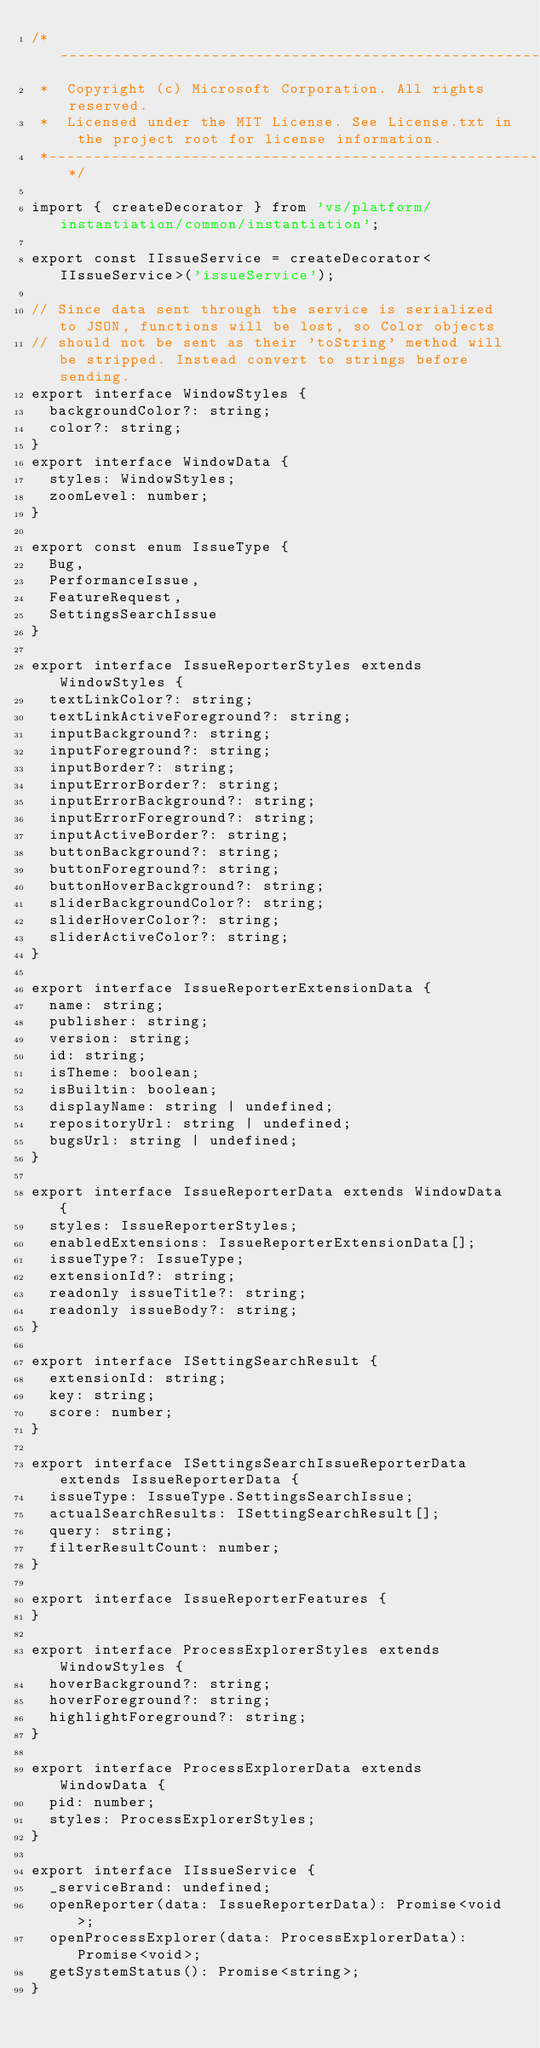<code> <loc_0><loc_0><loc_500><loc_500><_TypeScript_>/*---------------------------------------------------------------------------------------------
 *  Copyright (c) Microsoft Corporation. All rights reserved.
 *  Licensed under the MIT License. See License.txt in the project root for license information.
 *--------------------------------------------------------------------------------------------*/

import { createDecorator } from 'vs/platform/instantiation/common/instantiation';

export const IIssueService = createDecorator<IIssueService>('issueService');

// Since data sent through the service is serialized to JSON, functions will be lost, so Color objects
// should not be sent as their 'toString' method will be stripped. Instead convert to strings before sending.
export interface WindowStyles {
	backgroundColor?: string;
	color?: string;
}
export interface WindowData {
	styles: WindowStyles;
	zoomLevel: number;
}

export const enum IssueType {
	Bug,
	PerformanceIssue,
	FeatureRequest,
	SettingsSearchIssue
}

export interface IssueReporterStyles extends WindowStyles {
	textLinkColor?: string;
	textLinkActiveForeground?: string;
	inputBackground?: string;
	inputForeground?: string;
	inputBorder?: string;
	inputErrorBorder?: string;
	inputErrorBackground?: string;
	inputErrorForeground?: string;
	inputActiveBorder?: string;
	buttonBackground?: string;
	buttonForeground?: string;
	buttonHoverBackground?: string;
	sliderBackgroundColor?: string;
	sliderHoverColor?: string;
	sliderActiveColor?: string;
}

export interface IssueReporterExtensionData {
	name: string;
	publisher: string;
	version: string;
	id: string;
	isTheme: boolean;
	isBuiltin: boolean;
	displayName: string | undefined;
	repositoryUrl: string | undefined;
	bugsUrl: string | undefined;
}

export interface IssueReporterData extends WindowData {
	styles: IssueReporterStyles;
	enabledExtensions: IssueReporterExtensionData[];
	issueType?: IssueType;
	extensionId?: string;
	readonly issueTitle?: string;
	readonly issueBody?: string;
}

export interface ISettingSearchResult {
	extensionId: string;
	key: string;
	score: number;
}

export interface ISettingsSearchIssueReporterData extends IssueReporterData {
	issueType: IssueType.SettingsSearchIssue;
	actualSearchResults: ISettingSearchResult[];
	query: string;
	filterResultCount: number;
}

export interface IssueReporterFeatures {
}

export interface ProcessExplorerStyles extends WindowStyles {
	hoverBackground?: string;
	hoverForeground?: string;
	highlightForeground?: string;
}

export interface ProcessExplorerData extends WindowData {
	pid: number;
	styles: ProcessExplorerStyles;
}

export interface IIssueService {
	_serviceBrand: undefined;
	openReporter(data: IssueReporterData): Promise<void>;
	openProcessExplorer(data: ProcessExplorerData): Promise<void>;
	getSystemStatus(): Promise<string>;
}
</code> 